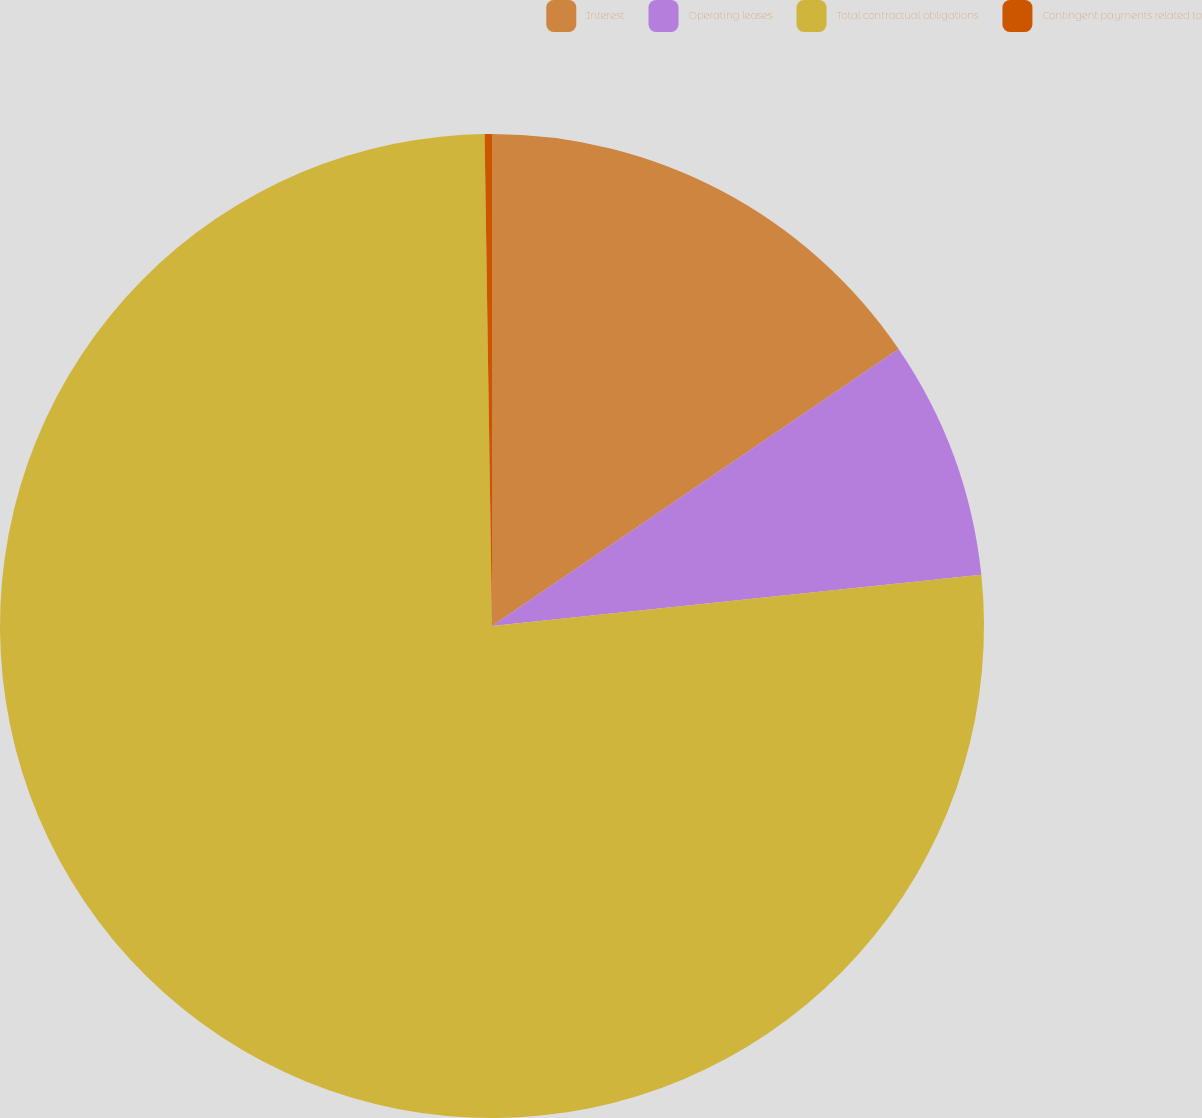<chart> <loc_0><loc_0><loc_500><loc_500><pie_chart><fcel>Interest<fcel>Operating leases<fcel>Total contractual obligations<fcel>Contingent payments related to<nl><fcel>15.48%<fcel>7.86%<fcel>76.42%<fcel>0.24%<nl></chart> 